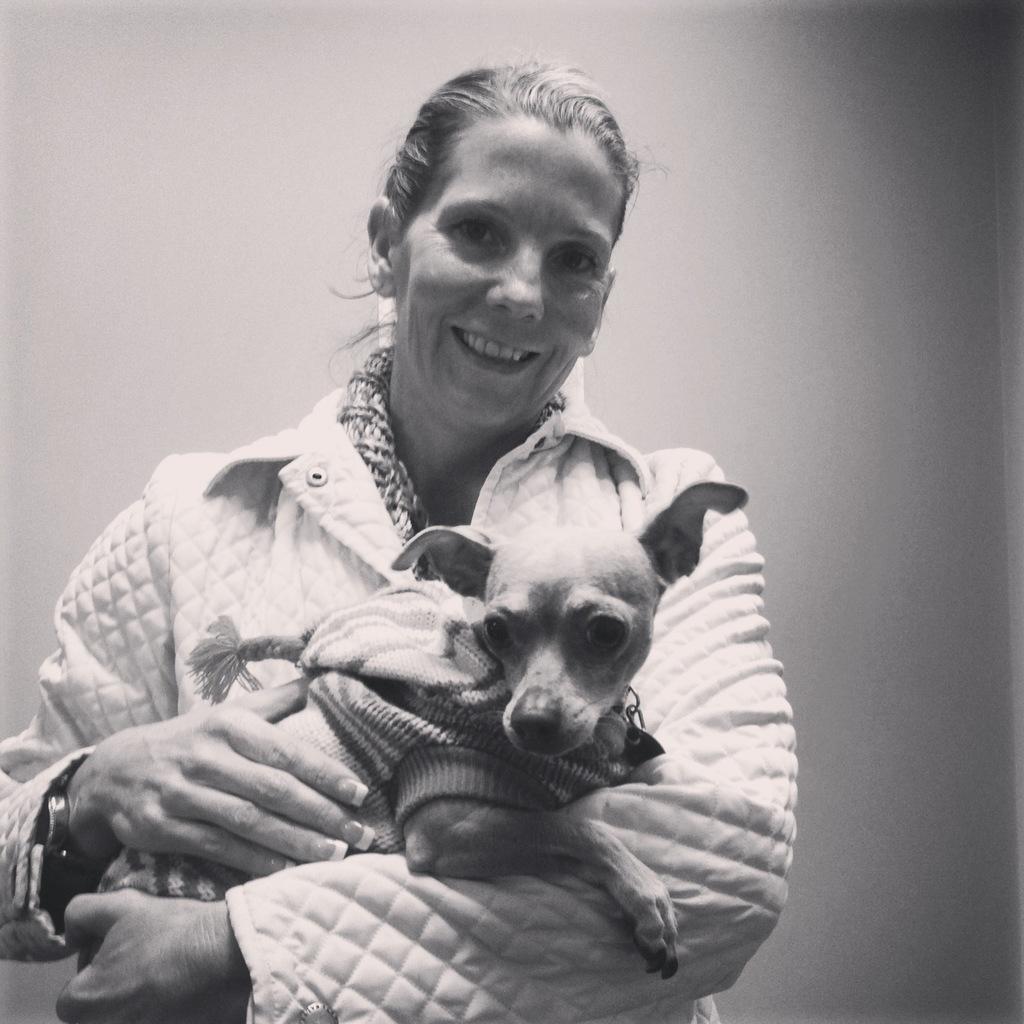Describe this image in one or two sentences. It is a black and white picture where one woman is standing in a white coat and she is holding a dog behind her there is a wall. 